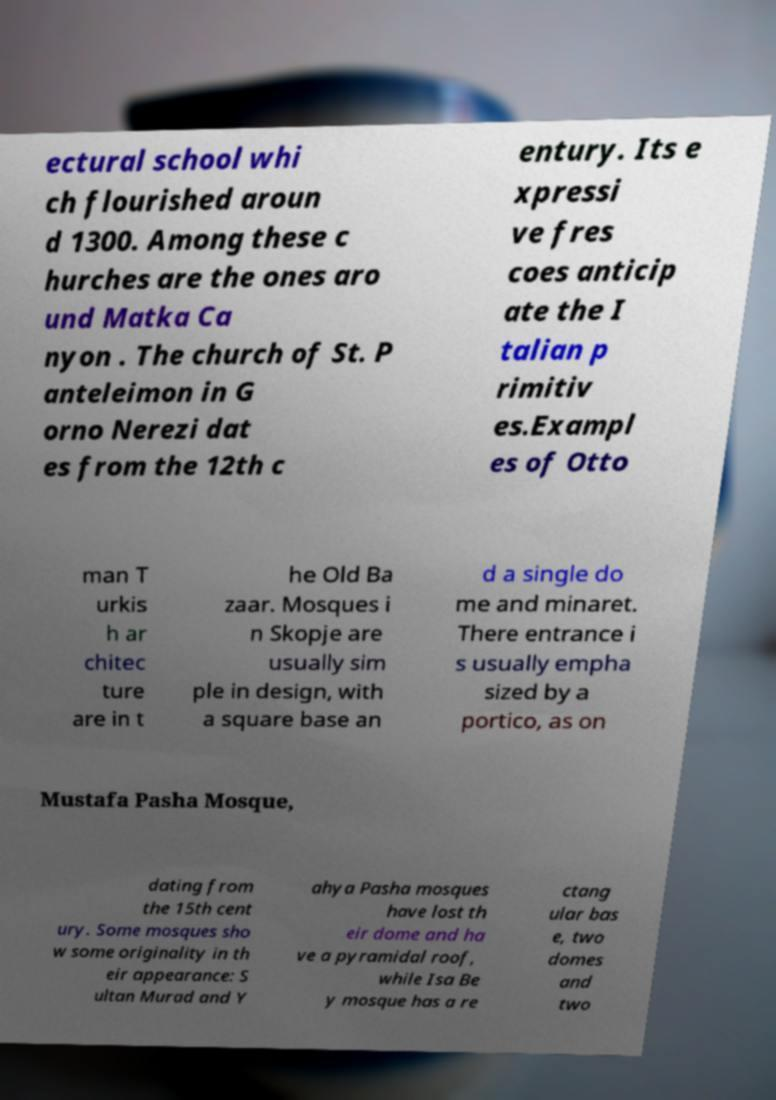Could you assist in decoding the text presented in this image and type it out clearly? ectural school whi ch flourished aroun d 1300. Among these c hurches are the ones aro und Matka Ca nyon . The church of St. P anteleimon in G orno Nerezi dat es from the 12th c entury. Its e xpressi ve fres coes anticip ate the I talian p rimitiv es.Exampl es of Otto man T urkis h ar chitec ture are in t he Old Ba zaar. Mosques i n Skopje are usually sim ple in design, with a square base an d a single do me and minaret. There entrance i s usually empha sized by a portico, as on Mustafa Pasha Mosque, dating from the 15th cent ury. Some mosques sho w some originality in th eir appearance: S ultan Murad and Y ahya Pasha mosques have lost th eir dome and ha ve a pyramidal roof, while Isa Be y mosque has a re ctang ular bas e, two domes and two 